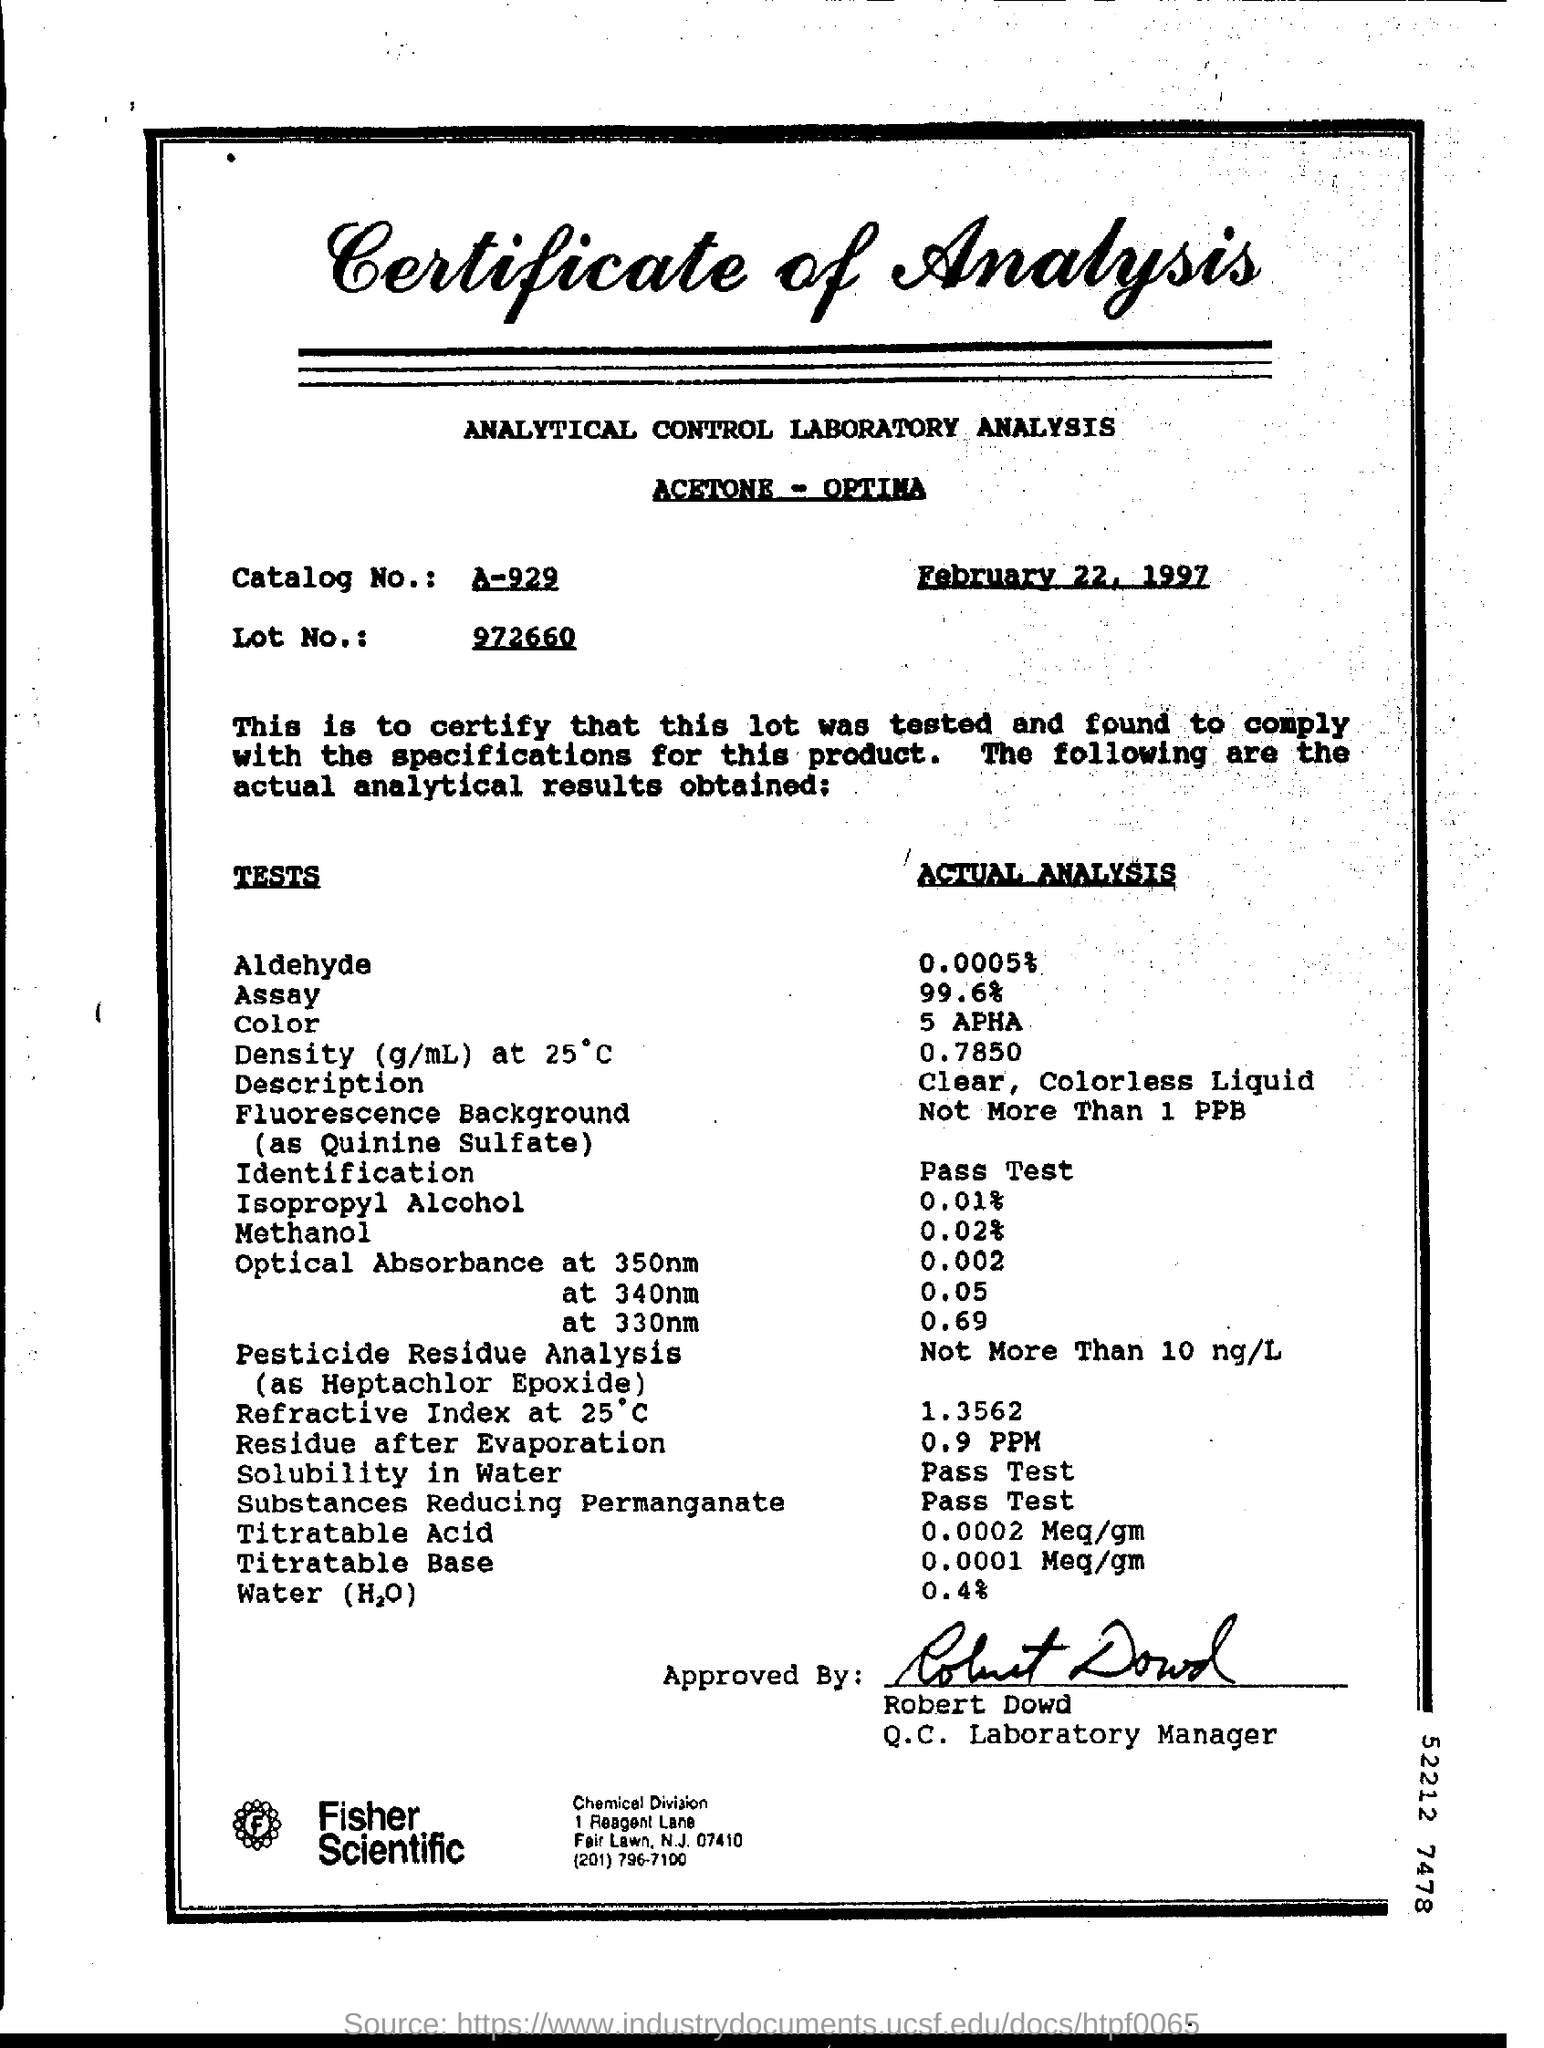Draw attention to some important aspects in this diagram. The certificate was dated February 22, 1997. The Catalog No. is A-929. The amount of residue after evaporation was 0.9 parts per million (ppm). The actual analysis revealed that 0.0005% of the substance is composed of aldehyde. The Lot number is 972660... 